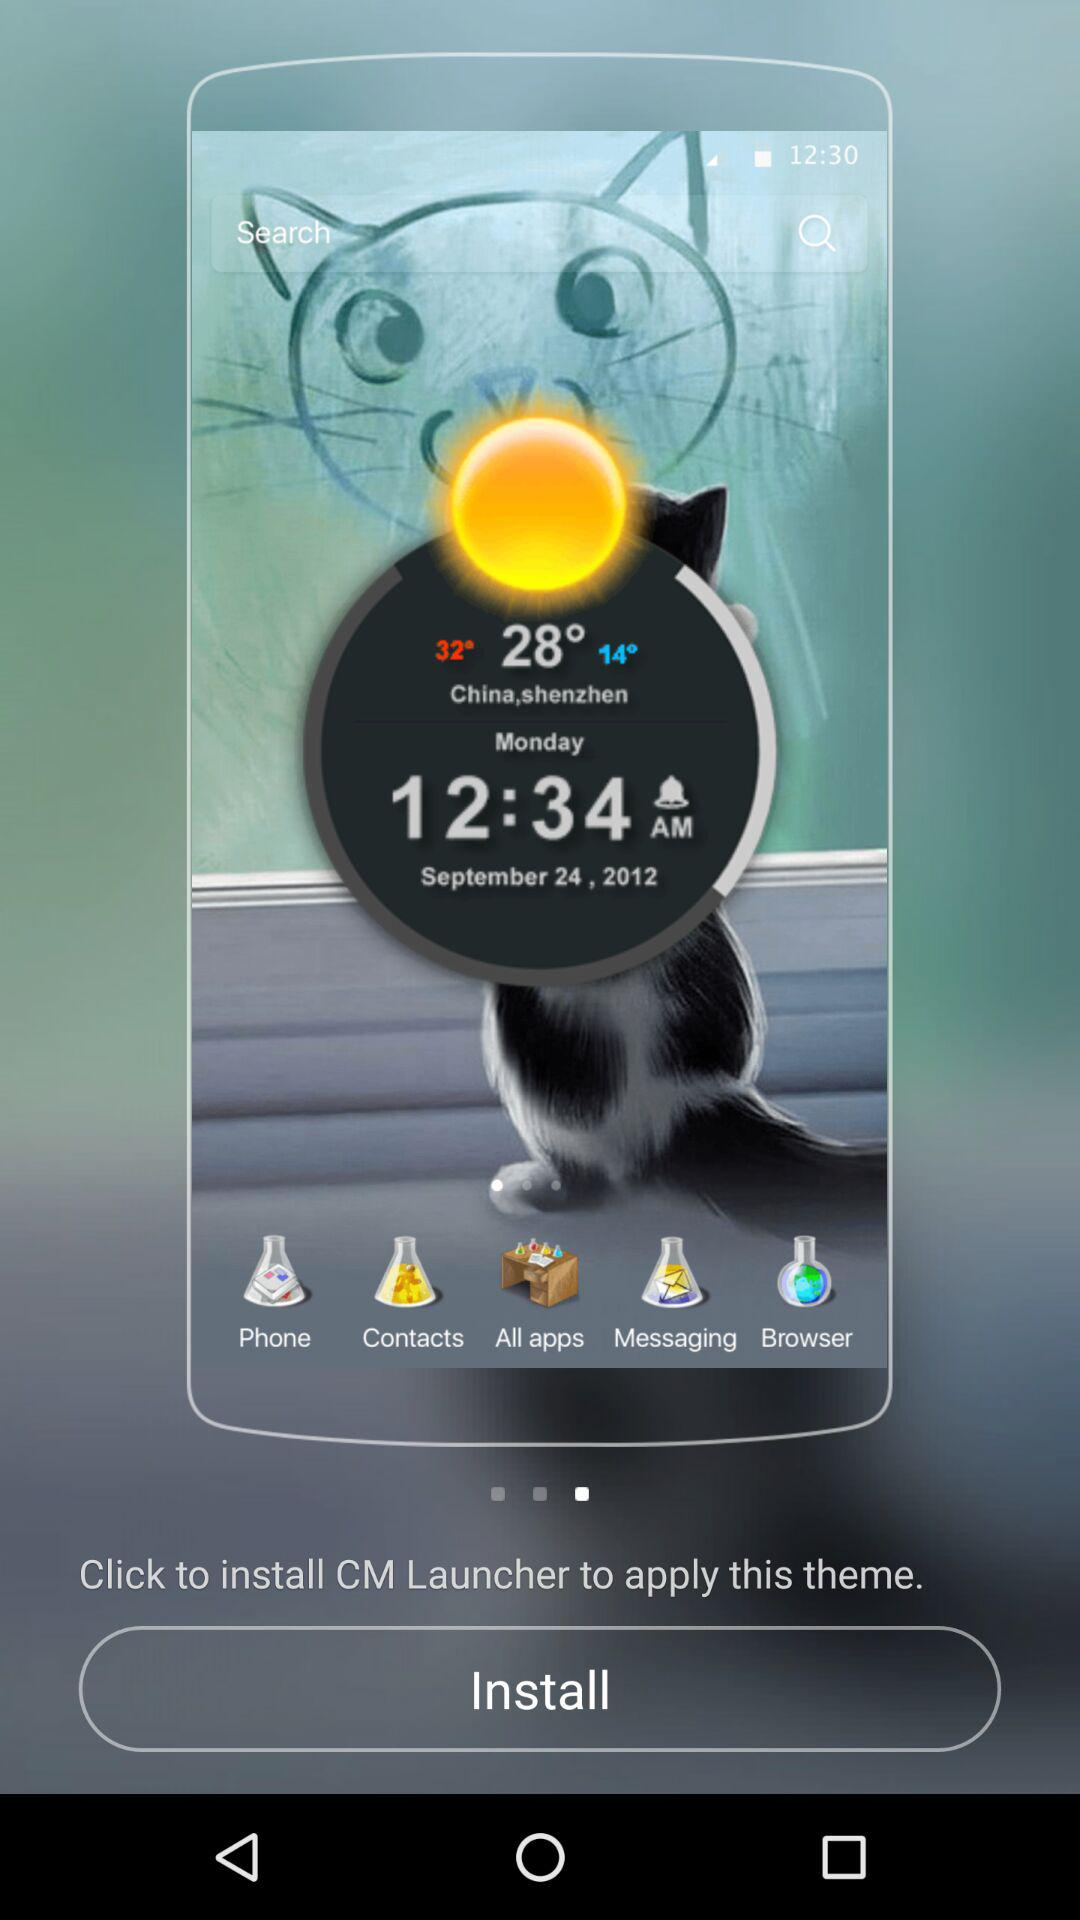What is the temperature right now? The temperature right now is 28°. 